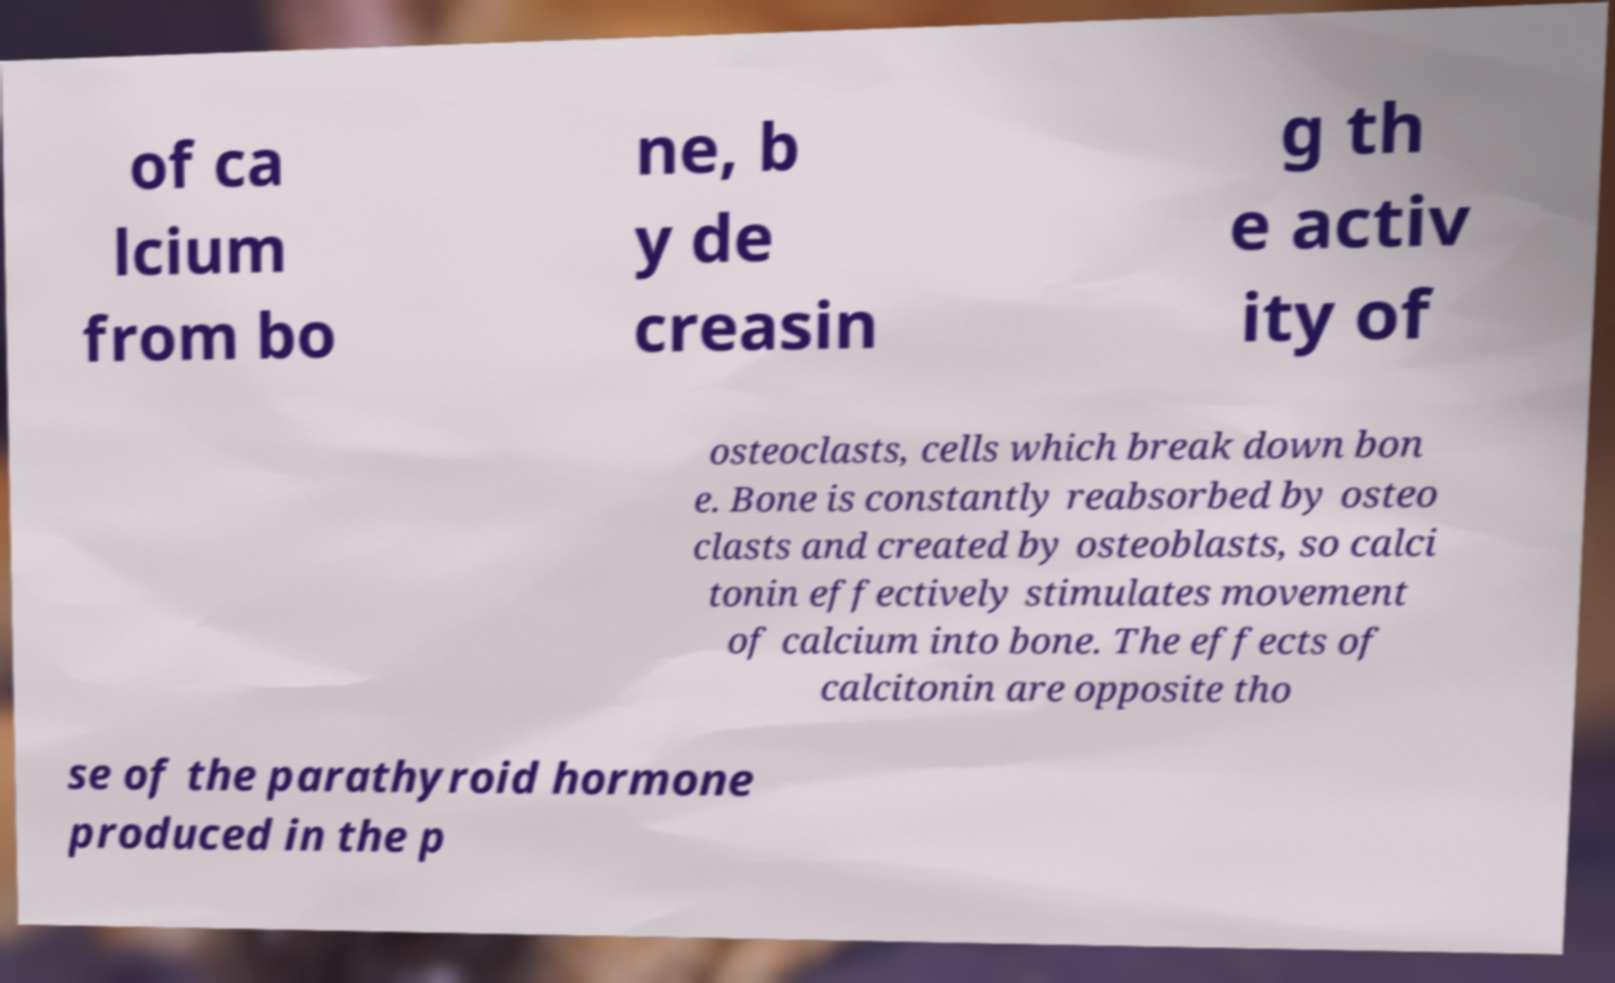Could you assist in decoding the text presented in this image and type it out clearly? of ca lcium from bo ne, b y de creasin g th e activ ity of osteoclasts, cells which break down bon e. Bone is constantly reabsorbed by osteo clasts and created by osteoblasts, so calci tonin effectively stimulates movement of calcium into bone. The effects of calcitonin are opposite tho se of the parathyroid hormone produced in the p 